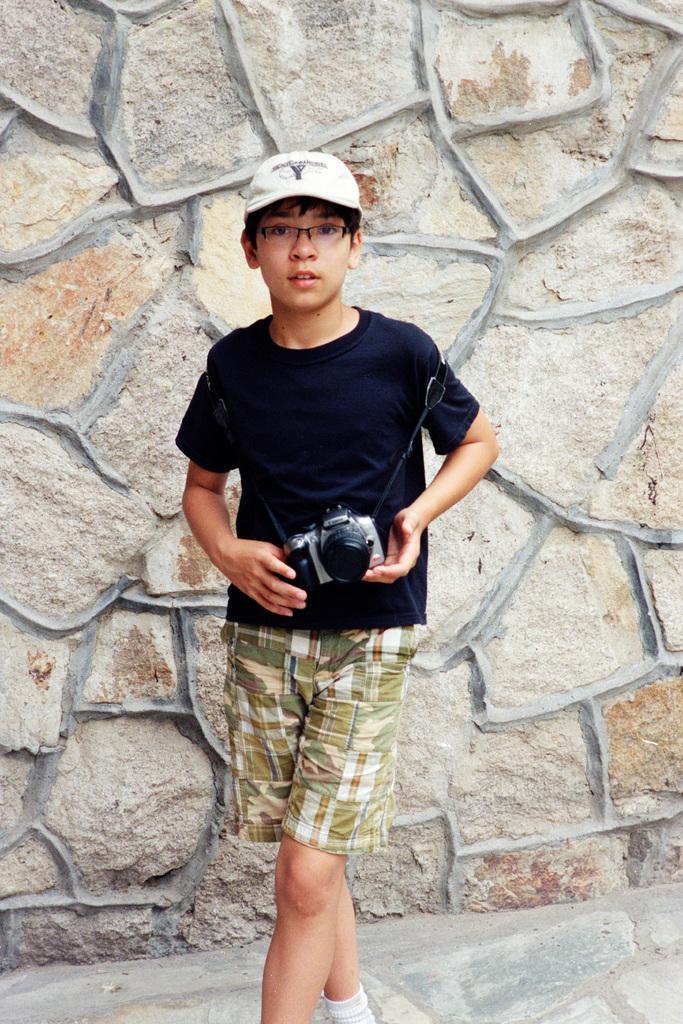How would you summarize this image in a sentence or two? In this picture i could see a person holding a camera in his hands wearing a black t shirt and green colored short. In the background i could see some stones. 